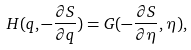<formula> <loc_0><loc_0><loc_500><loc_500>H ( q , - \frac { \partial S } { \partial q } ) = G ( - \frac { \partial S } { \partial \eta } , \eta ) ,</formula> 